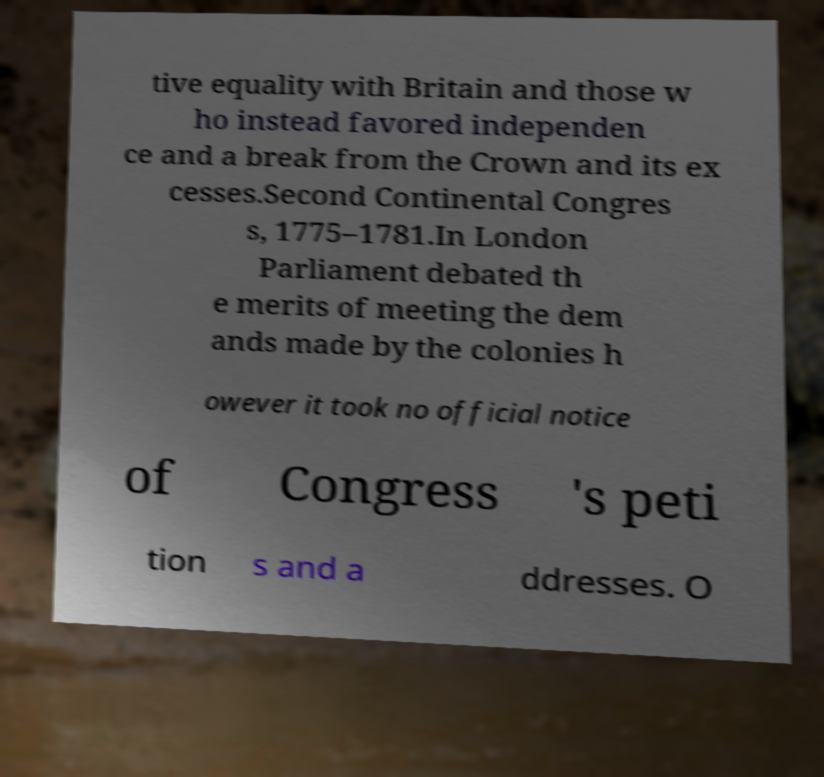There's text embedded in this image that I need extracted. Can you transcribe it verbatim? tive equality with Britain and those w ho instead favored independen ce and a break from the Crown and its ex cesses.Second Continental Congres s, 1775–1781.In London Parliament debated th e merits of meeting the dem ands made by the colonies h owever it took no official notice of Congress 's peti tion s and a ddresses. O 